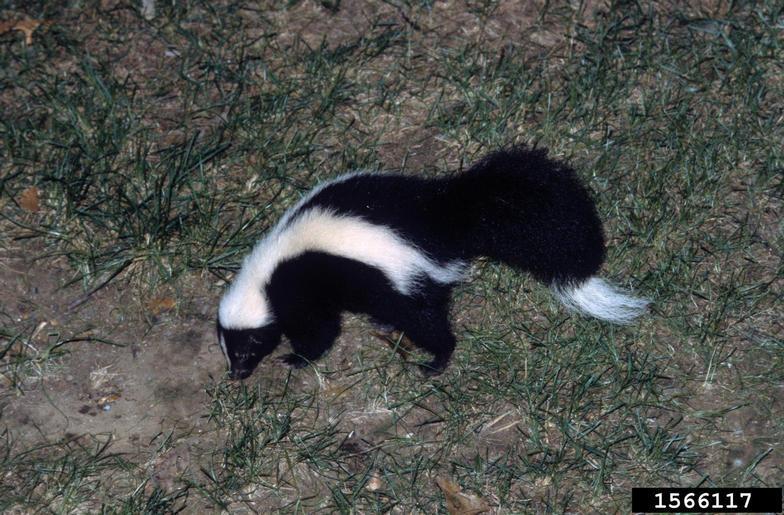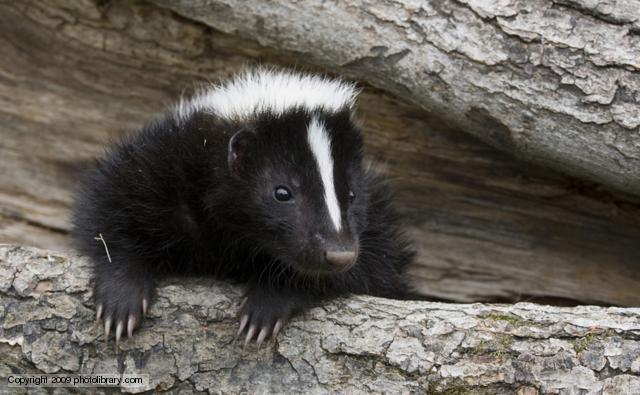The first image is the image on the left, the second image is the image on the right. Considering the images on both sides, is "there is a skunk peaking out from a fallen tree trunk with just the front part of it's bidy visible" valid? Answer yes or no. Yes. 